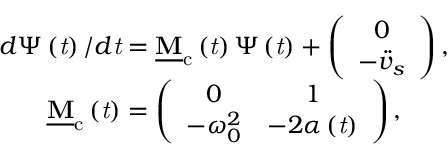Convert formula to latex. <formula><loc_0><loc_0><loc_500><loc_500>\begin{array} { c } { d \Psi \left ( t \right ) / d t = \underline { M } _ { c } \left ( t \right ) \Psi \left ( t \right ) + \left ( \begin{array} { c } { 0 } \\ { - \ddot { v } _ { s } } \end{array} \right ) , } \\ { \underline { M } _ { c } \left ( t \right ) = \left ( \begin{array} { c c } { 0 } & { 1 } \\ { - \omega _ { 0 } ^ { 2 } } & { - 2 \alpha \left ( t \right ) } \end{array} \right ) , } \end{array}</formula> 